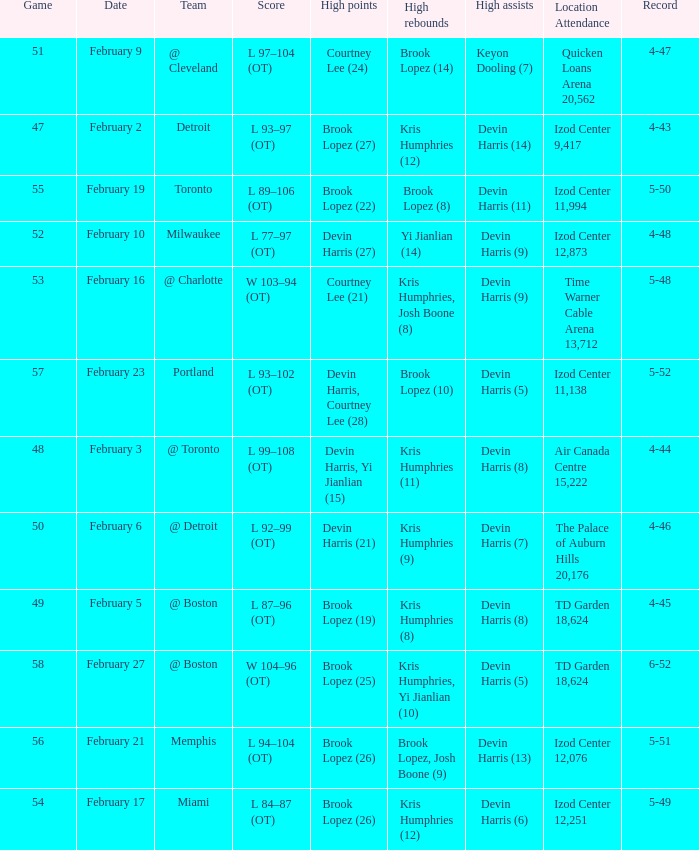What team was the game on February 27 played against? @ Boston. 